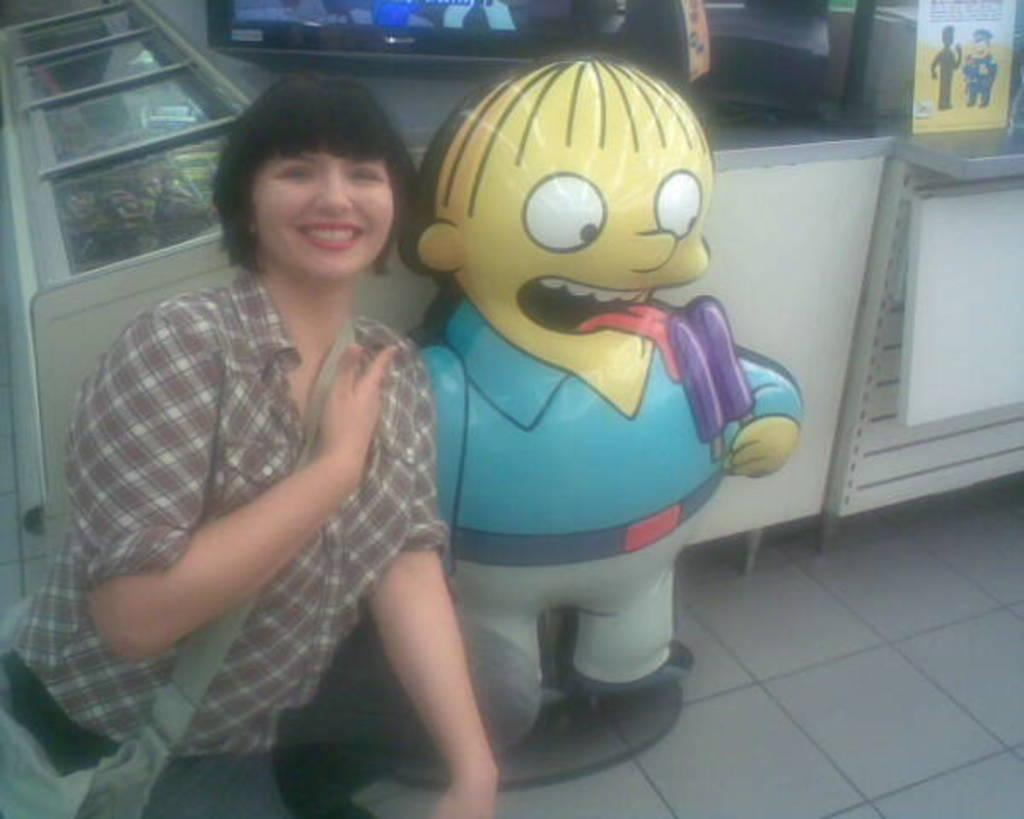Who is present in the image? There is a woman in the image. What is the woman wearing? The woman is wearing a bag. What expression does the woman have? The woman is smiling. What can be seen in the background of the image? There is an air balloon in the image. What electronic device is present in the image? There is a television in the image. Can you see a toad hopping near the television in the image? A: There is no toad present in the image. What wish does the woman make while holding the bag in the image? The image does not provide any information about the woman making a wish or holding a bag for that purpose. 